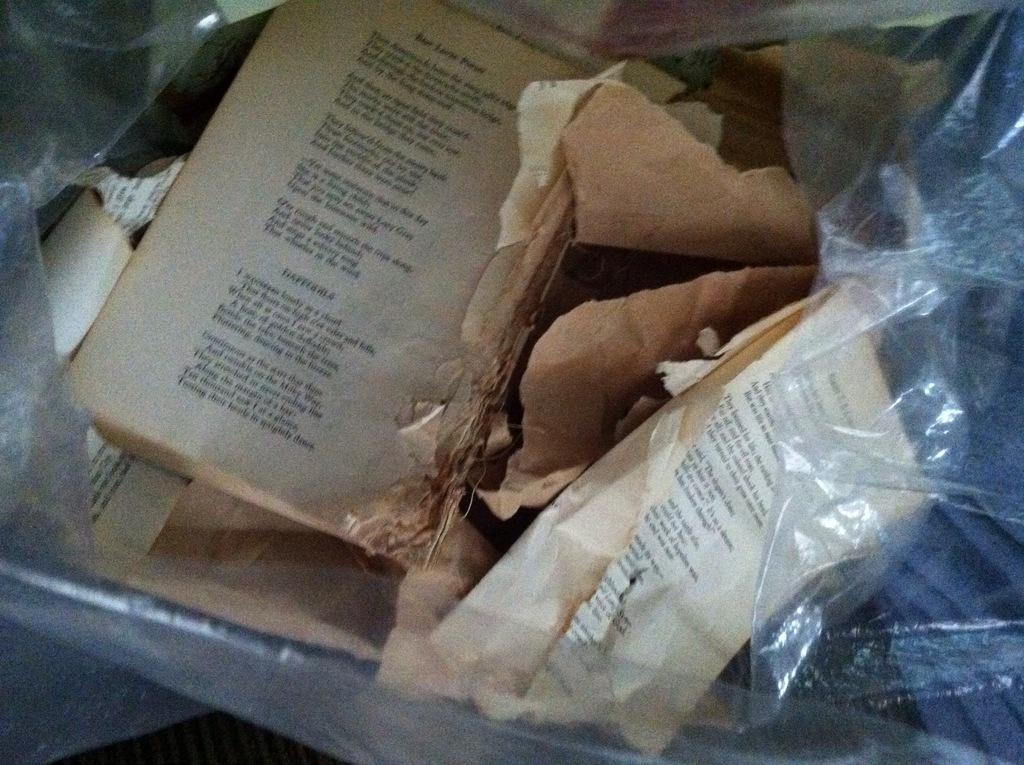How would you summarize this image in a sentence or two? In this image we can see the pages of a book is present in a cover. 